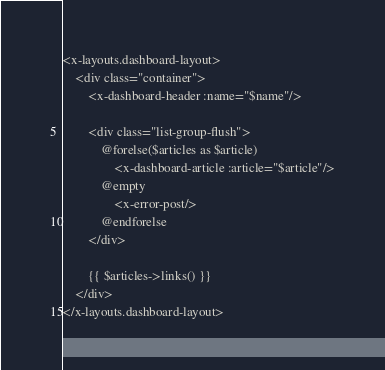<code> <loc_0><loc_0><loc_500><loc_500><_PHP_><x-layouts.dashboard-layout>
    <div class="container">
        <x-dashboard-header :name="$name"/>

        <div class="list-group-flush">
            @forelse($articles as $article)
                <x-dashboard-article :article="$article"/>
            @empty
                <x-error-post/>
            @endforelse
        </div>

        {{ $articles->links() }}
    </div>
</x-layouts.dashboard-layout>
</code> 